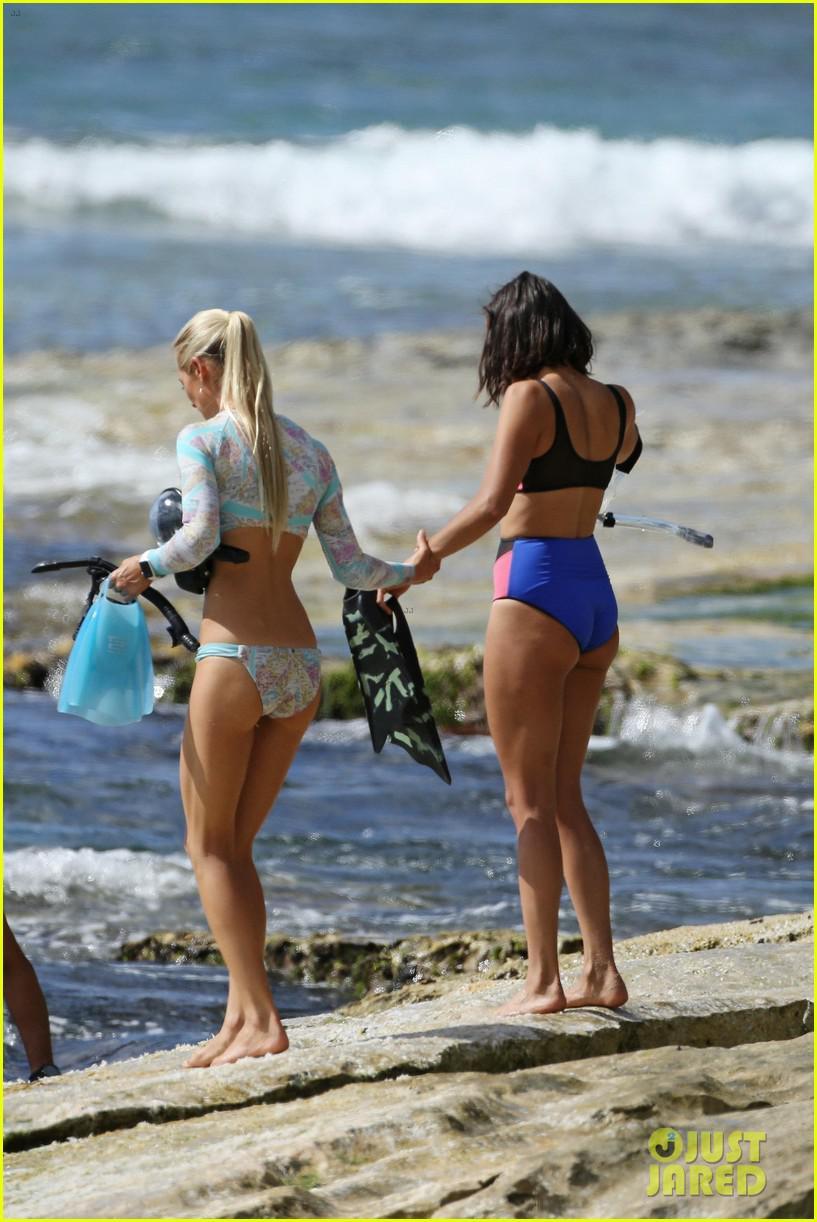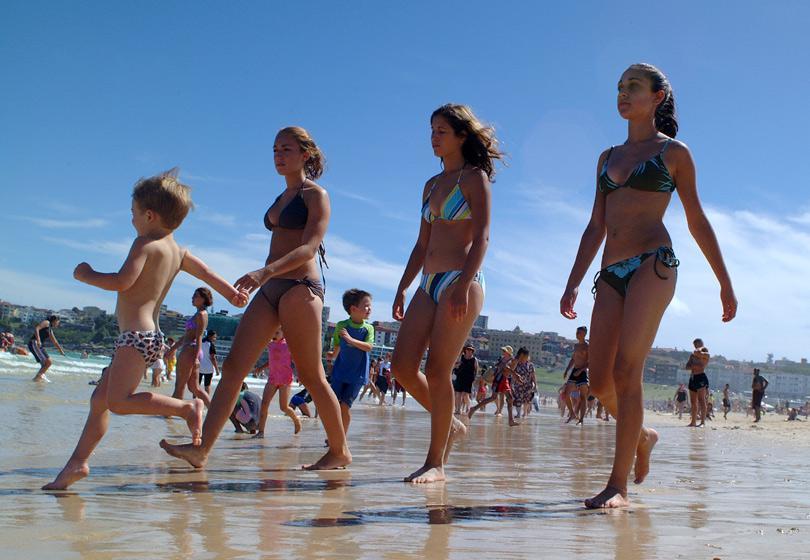The first image is the image on the left, the second image is the image on the right. Assess this claim about the two images: "Three women are in swimsuits near the water.". Correct or not? Answer yes or no. No. 